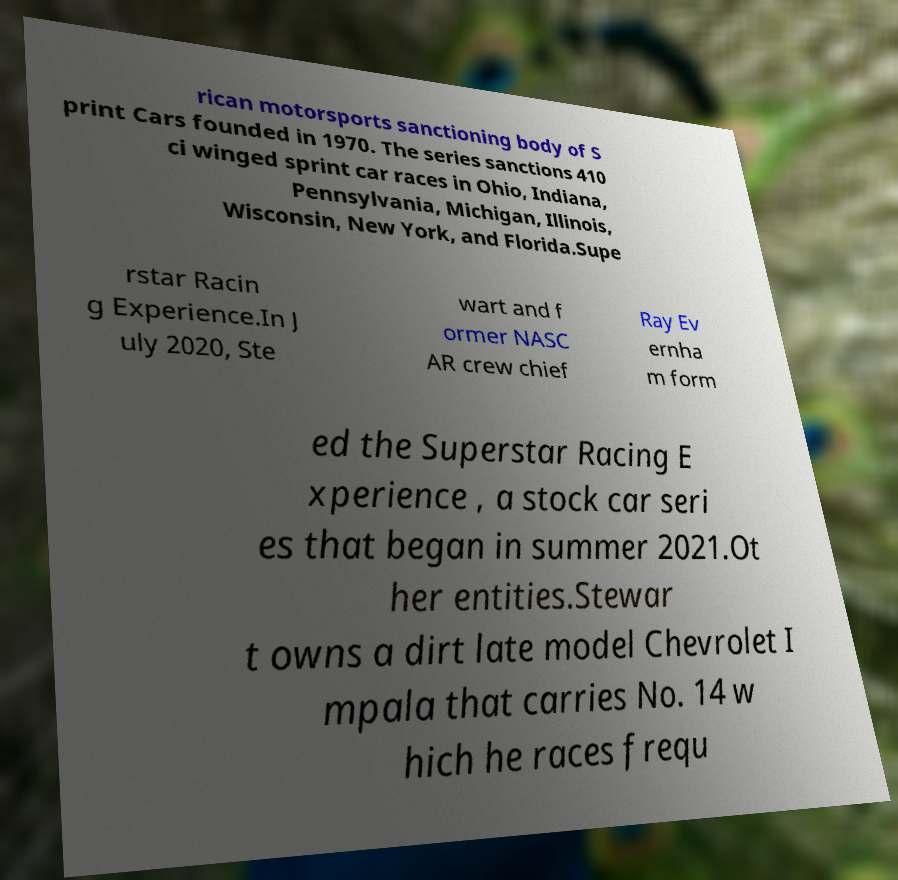Could you extract and type out the text from this image? rican motorsports sanctioning body of S print Cars founded in 1970. The series sanctions 410 ci winged sprint car races in Ohio, Indiana, Pennsylvania, Michigan, Illinois, Wisconsin, New York, and Florida.Supe rstar Racin g Experience.In J uly 2020, Ste wart and f ormer NASC AR crew chief Ray Ev ernha m form ed the Superstar Racing E xperience , a stock car seri es that began in summer 2021.Ot her entities.Stewar t owns a dirt late model Chevrolet I mpala that carries No. 14 w hich he races frequ 